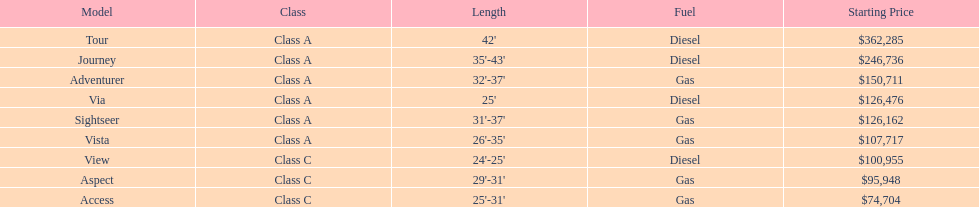What is the combined cost of both the via and tour models? $488,761. Would you be able to parse every entry in this table? {'header': ['Model', 'Class', 'Length', 'Fuel', 'Starting Price'], 'rows': [['Tour', 'Class A', "42'", 'Diesel', '$362,285'], ['Journey', 'Class A', "35'-43'", 'Diesel', '$246,736'], ['Adventurer', 'Class A', "32'-37'", 'Gas', '$150,711'], ['Via', 'Class A', "25'", 'Diesel', '$126,476'], ['Sightseer', 'Class A', "31'-37'", 'Gas', '$126,162'], ['Vista', 'Class A', "26'-35'", 'Gas', '$107,717'], ['View', 'Class C', "24'-25'", 'Diesel', '$100,955'], ['Aspect', 'Class C', "29'-31'", 'Gas', '$95,948'], ['Access', 'Class C', "25'-31'", 'Gas', '$74,704']]} 